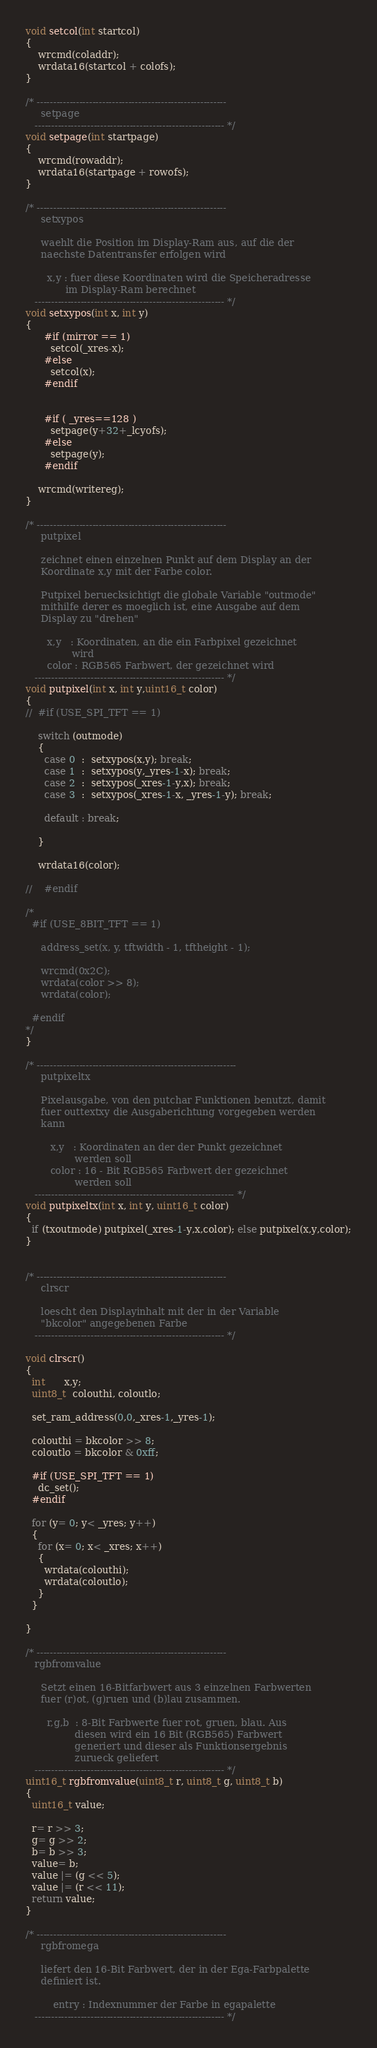<code> <loc_0><loc_0><loc_500><loc_500><_C_>void setcol(int startcol)
{
    wrcmd(coladdr);
    wrdata16(startcol + colofs);
}

/* ----------------------------------------------------------
     setpage
   ---------------------------------------------------------- */
void setpage(int startpage)
{
    wrcmd(rowaddr);
    wrdata16(startpage + rowofs);
}

/* ----------------------------------------------------------
     setxypos

     waehlt die Position im Display-Ram aus, auf die der
     naechste Datentransfer erfolgen wird

       x,y : fuer diese Koordinaten wird die Speicheradresse
             im Display-Ram berechnet
   ---------------------------------------------------------- */
void setxypos(int x, int y)
{
      #if (mirror == 1)
        setcol(_xres-x);
      #else
        setcol(x);
      #endif


      #if ( _yres==128 )
        setpage(y+32+_lcyofs);
      #else
        setpage(y);
      #endif

    wrcmd(writereg);
}

/* ----------------------------------------------------------
     putpixel

     zeichnet einen einzelnen Punkt auf dem Display an der
     Koordinate x,y mit der Farbe color.

     Putpixel beruecksichtigt die globale Variable "outmode"
     mithilfe derer es moeglich ist, eine Ausgabe auf dem
     Display zu "drehen"

       x,y   : Koordinaten, an die ein Farbpixel gezeichnet
               wird
       color : RGB565 Farbwert, der gezeichnet wird
   ---------------------------------------------------------- */
void putpixel(int x, int y,uint16_t color)
{
//  #if (USE_SPI_TFT == 1)

    switch (outmode)
    {
      case 0  :  setxypos(x,y); break;
      case 1  :  setxypos(y,_yres-1-x); break;
      case 2  :  setxypos(_xres-1-y,x); break;
      case 3  :  setxypos(_xres-1-x, _yres-1-y); break;

      default : break;

    }

    wrdata16(color);

//    #endif

/*
  #if (USE_8BIT_TFT == 1)

     address_set(x, y, tftwidth - 1, tftheight - 1);

     wrcmd(0x2C);
     wrdata(color >> 8);
     wrdata(color);

  #endif
*/
}

/* -------------------------------------------------------------
     putpixeltx

     Pixelausgabe, von den putchar Funktionen benutzt, damit
     fuer outtextxy die Ausgaberichtung vorgegeben werden
     kann

        x,y   : Koordinaten an der der Punkt gezeichnet
                werden soll
        color : 16 - Bit RGB565 Farbwert der gezeichnet
                werden soll
   ------------------------------------------------------------- */
void putpixeltx(int x, int y, uint16_t color)
{
  if (txoutmode) putpixel(_xres-1-y,x,color); else putpixel(x,y,color);
}


/* ----------------------------------------------------------
     clrscr

     loescht den Displayinhalt mit der in der Variable
     "bkcolor" angegebenen Farbe
   ---------------------------------------------------------- */

void clrscr()
{
  int      x,y;
  uint8_t  colouthi, coloutlo;

  set_ram_address(0,0,_xres-1,_yres-1);

  colouthi = bkcolor >> 8;
  coloutlo = bkcolor & 0xff;

  #if (USE_SPI_TFT == 1)
    dc_set();
  #endif

  for (y= 0; y< _yres; y++)
  {
    for (x= 0; x< _xres; x++)
    {
      wrdata(colouthi);
      wrdata(coloutlo);
    }
  }

}

/* ----------------------------------------------------------
   rgbfromvalue

     Setzt einen 16-Bitfarbwert aus 3 einzelnen Farbwerten
     fuer (r)ot, (g)ruen und (b)lau zusammen.

       r,g,b  : 8-Bit Farbwerte fuer rot, gruen, blau. Aus
                diesen wird ein 16 Bit (RGB565) Farbwert
                generiert und dieser als Funktionsergebnis
                zurueck geliefert
   ---------------------------------------------------------- */
uint16_t rgbfromvalue(uint8_t r, uint8_t g, uint8_t b)
{
  uint16_t value;

  r= r >> 3;
  g= g >> 2;
  b= b >> 3;
  value= b;
  value |= (g << 5);
  value |= (r << 11);
  return value;
}

/* ----------------------------------------------------------
     rgbfromega

     liefert den 16-Bit Farbwert, der in der Ega-Farbpalette
     definiert ist.

         entry : Indexnummer der Farbe in egapalette
   ---------------------------------------------------------- */
</code> 